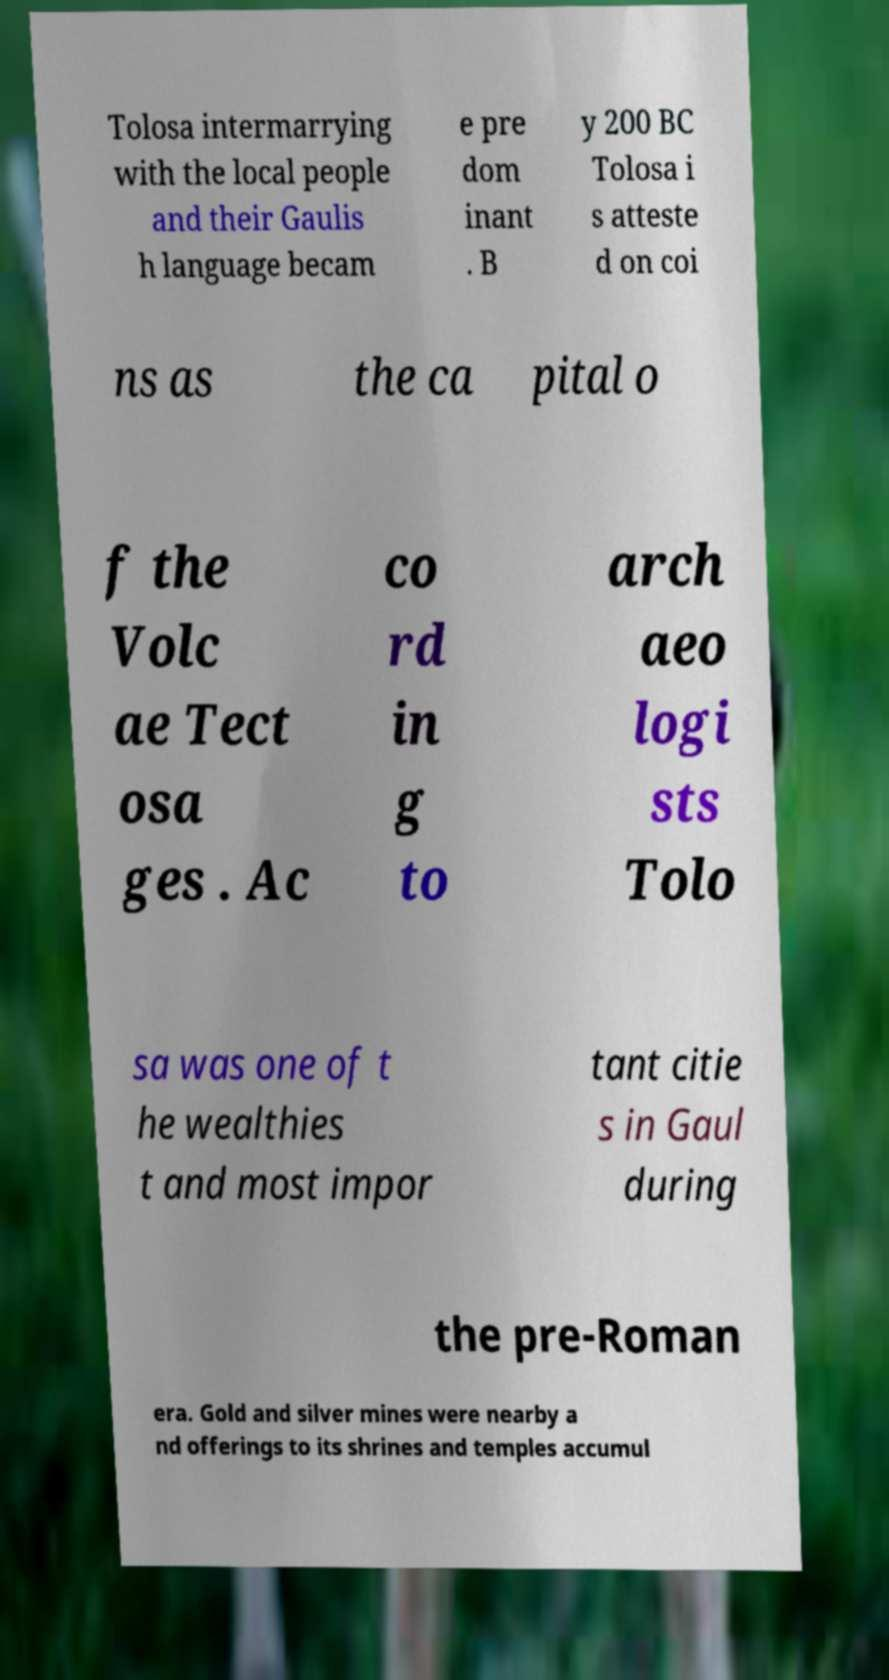Could you assist in decoding the text presented in this image and type it out clearly? Tolosa intermarrying with the local people and their Gaulis h language becam e pre dom inant . B y 200 BC Tolosa i s atteste d on coi ns as the ca pital o f the Volc ae Tect osa ges . Ac co rd in g to arch aeo logi sts Tolo sa was one of t he wealthies t and most impor tant citie s in Gaul during the pre-Roman era. Gold and silver mines were nearby a nd offerings to its shrines and temples accumul 